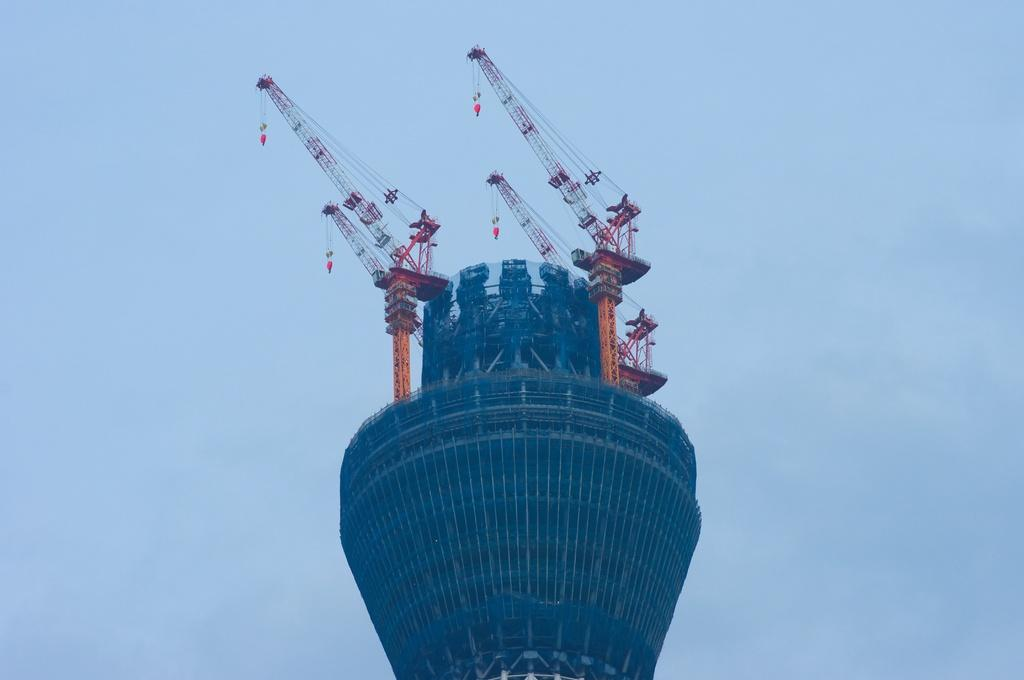What structure is the main subject of the image? There is a building in the image. What can be seen on top of the building? There are cranes on top of the building. What is visible at the top of the image? The sky is visible at the top of the image. How many cows can be seen grazing in the waves near the building? There are no cows or waves present in the image; it features a building with cranes on top. 